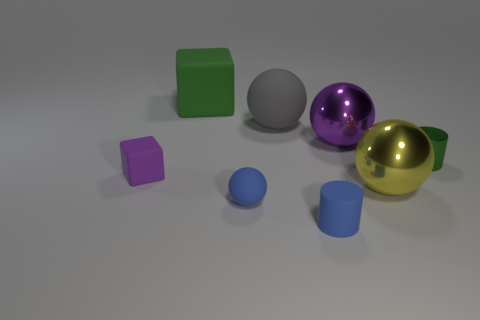There is a small metallic thing; is its color the same as the cube that is to the left of the large cube?
Offer a very short reply. No. What color is the big cube?
Your answer should be very brief. Green. What is the material of the cylinder that is on the right side of the yellow metal thing?
Ensure brevity in your answer.  Metal. What is the size of the blue object that is the same shape as the large gray matte thing?
Give a very brief answer. Small. Is the number of purple metallic balls in front of the tiny block less than the number of small purple metallic spheres?
Your answer should be very brief. No. Are any yellow metallic cylinders visible?
Ensure brevity in your answer.  No. What color is the other metallic thing that is the same shape as the large purple shiny object?
Offer a terse response. Yellow. There is a tiny cylinder behind the small purple matte cube; does it have the same color as the tiny rubber cylinder?
Give a very brief answer. No. Do the blue matte cylinder and the green block have the same size?
Provide a succinct answer. No. What is the shape of the big thing that is the same material as the large yellow sphere?
Your answer should be very brief. Sphere. 